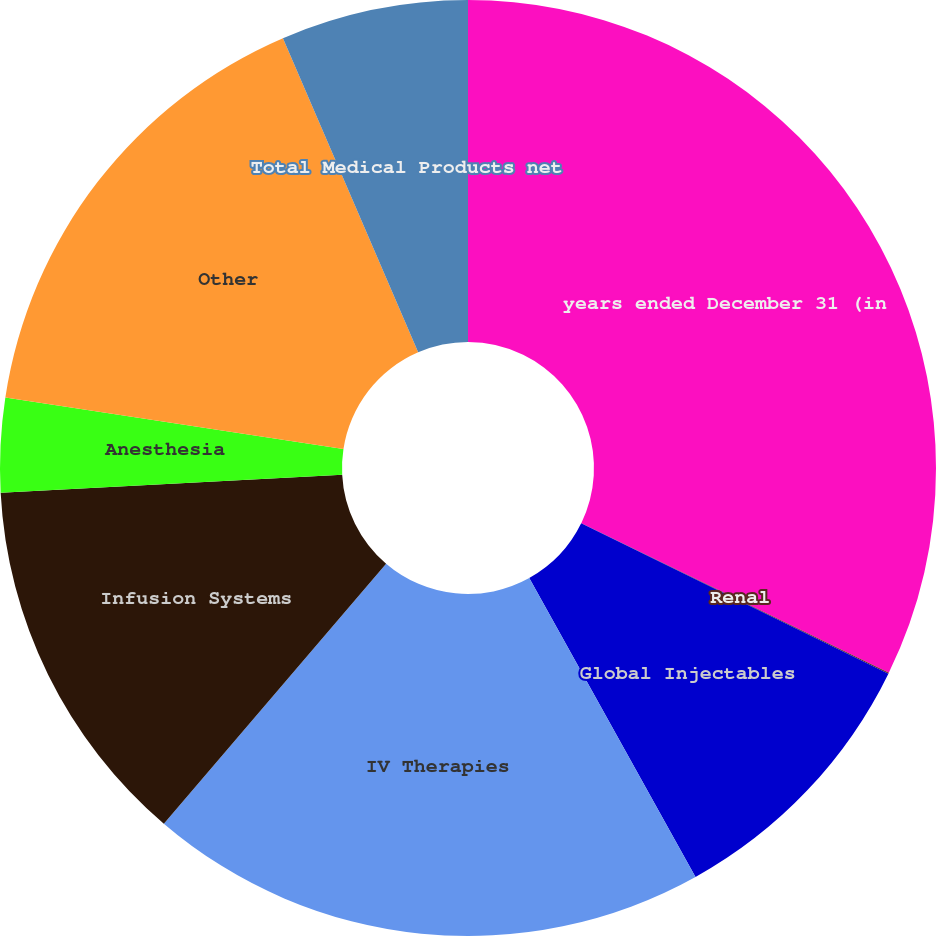Convert chart. <chart><loc_0><loc_0><loc_500><loc_500><pie_chart><fcel>years ended December 31 (in<fcel>Renal<fcel>Global Injectables<fcel>IV Therapies<fcel>Infusion Systems<fcel>Anesthesia<fcel>Other<fcel>Total Medical Products net<nl><fcel>32.21%<fcel>0.03%<fcel>9.68%<fcel>19.34%<fcel>12.9%<fcel>3.25%<fcel>16.12%<fcel>6.47%<nl></chart> 